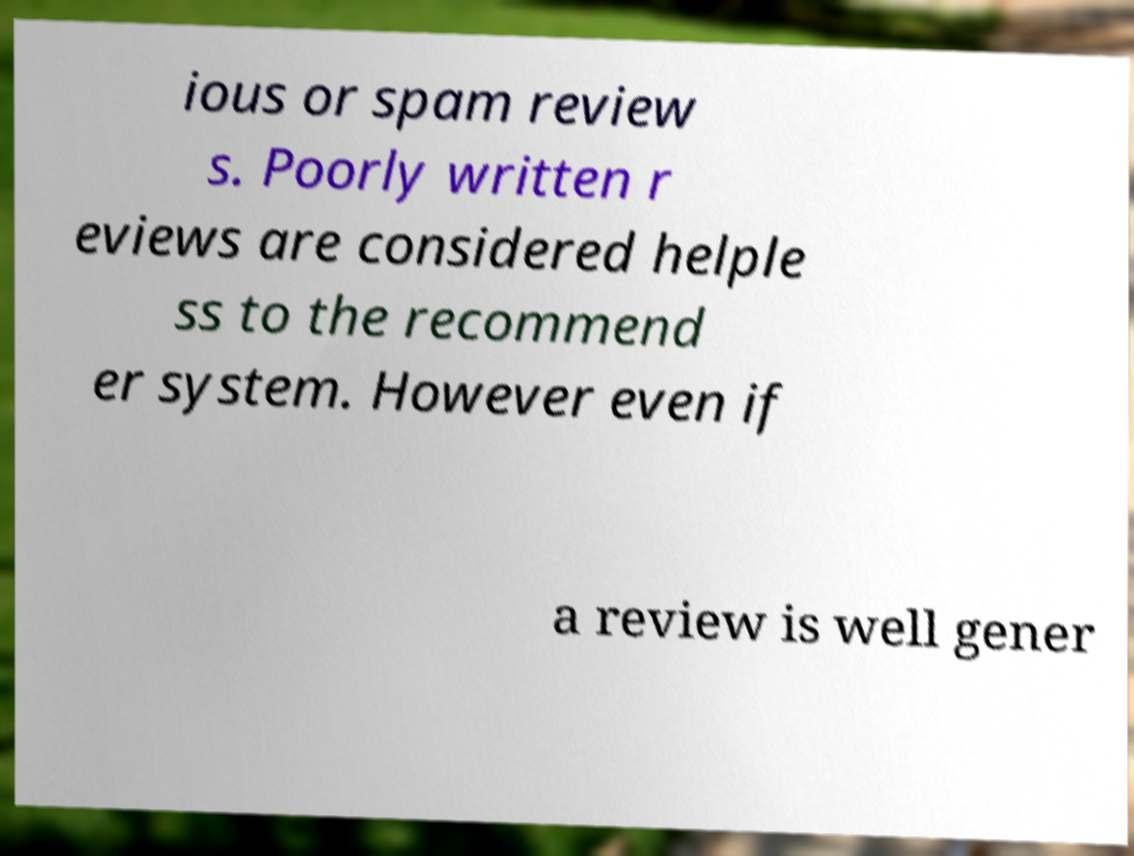I need the written content from this picture converted into text. Can you do that? ious or spam review s. Poorly written r eviews are considered helple ss to the recommend er system. However even if a review is well gener 